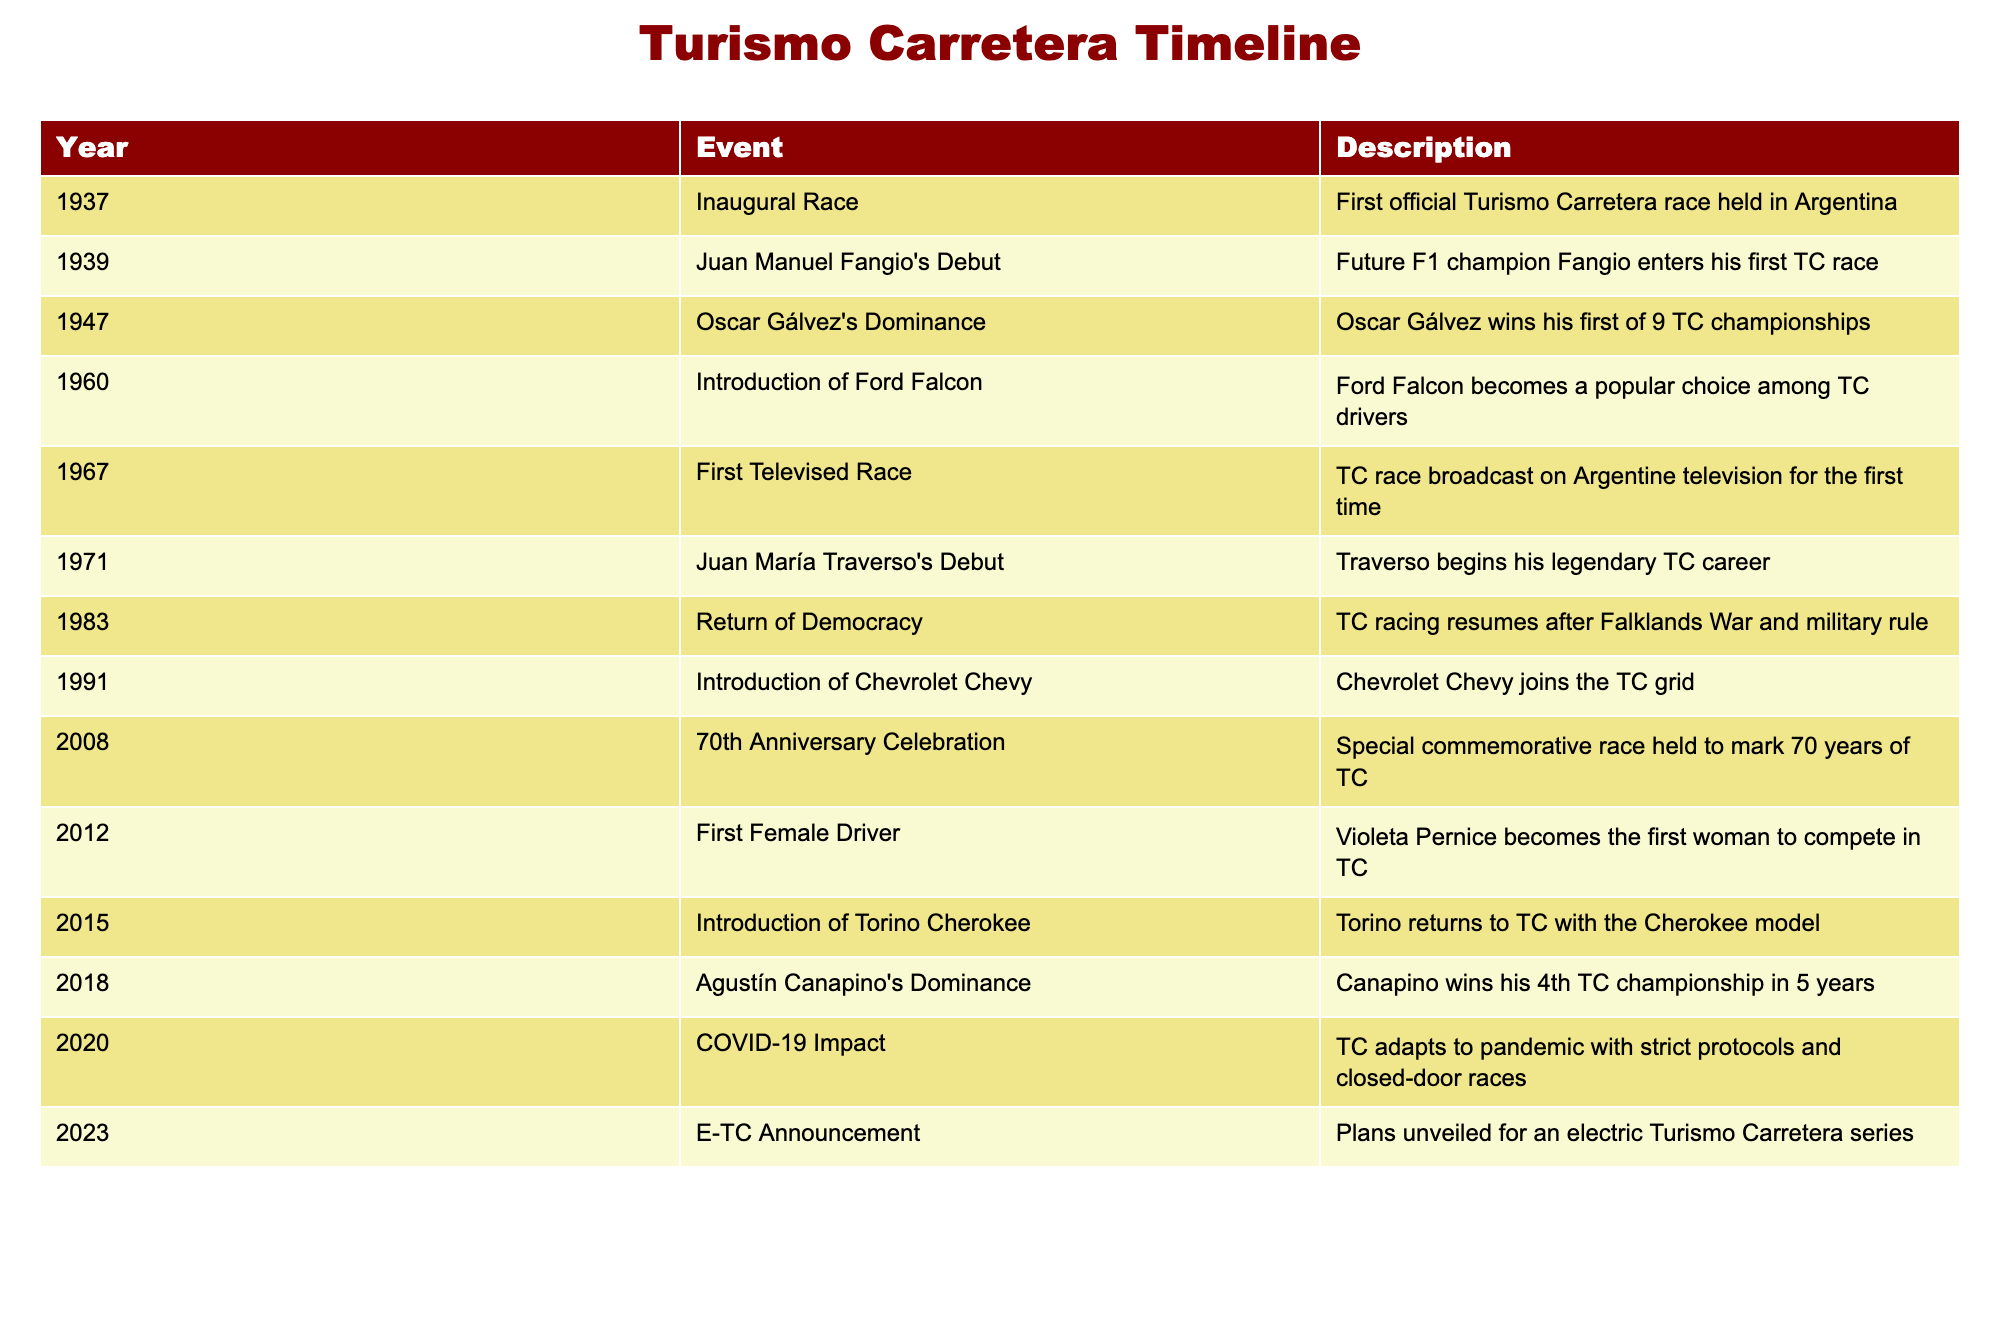What year was the first official Turismo Carretera race held? The table indicates that the inaugural race took place in 1937.
Answer: 1937 Who won his first Turismo Carretera championship in 1947? According to the table, Oscar Gálvez won his first of nine TC championships in 1947.
Answer: Oscar Gálvez Is Juan María Traverso's debut before or after the first televised race in Turismo Carretera? Juan María Traverso made his debut in 1971, whereas the first televised race occurred in 1967, making Traverso's debut after the televised race.
Answer: After How many championships did Agustín Canapino win from 2018 to 2023? The table specifies that Agustín Canapino won his fourth championship in 2018 and continues to dominate, which implies he has four championships as of that year, with no additional championships mentioned through 2023.
Answer: 4 What was a significant change in Turismo Carretera in 2008? The table states that in 2008, a special commemorative race was held to mark the 70th anniversary of Turismo Carretera.
Answer: 70th Anniversary Celebration Compare the significance of the introduction of the Ford Falcon in 1960 to the introduction of the Chevrolet Chevy in 1991. The Ford Falcon emerged in 1960 as a popular choice among drivers, shaping the competitive landscape of Turismo Carretera, while the Chevrolet Chevy joined the grid in 1991, indicating a change in manufacturer participation. Both indicate notable shifts in vehicle popularity but at different times impacting competition.
Answer: Ford Falcon and Chevrolet Chevy were both significant What adaptation did Turismo Carretera undertake due to the COVID-19 pandemic in 2020? The table mentions that in 2020, Turismo Carretera adapted to the pandemic with strict protocols and closed-door races to ensure safety while continuing the competition.
Answer: Strict protocols and closed-door races What trend can be observed regarding female participation in Turismo Carretera from its inception through 2012? The table indicates that 2012 saw the introduction of the first female driver, Violeta Pernice, highlighting a previously male-dominated sport beginning to include female drivers. This trend suggests a slow evolution towards inclusivity in the sport.
Answer: Introduction of first female driver in 2012 What was the historical significance of the event in 1983 within the context of Argentine history? The table notes that Turismo Carretera racing resumed in 1983 after the Falklands War and military rule, which indicates that the return of this popular sport was significant for the national psyche and restoration of normalcy in Argentina.
Answer: Resumption of racing after military rule 